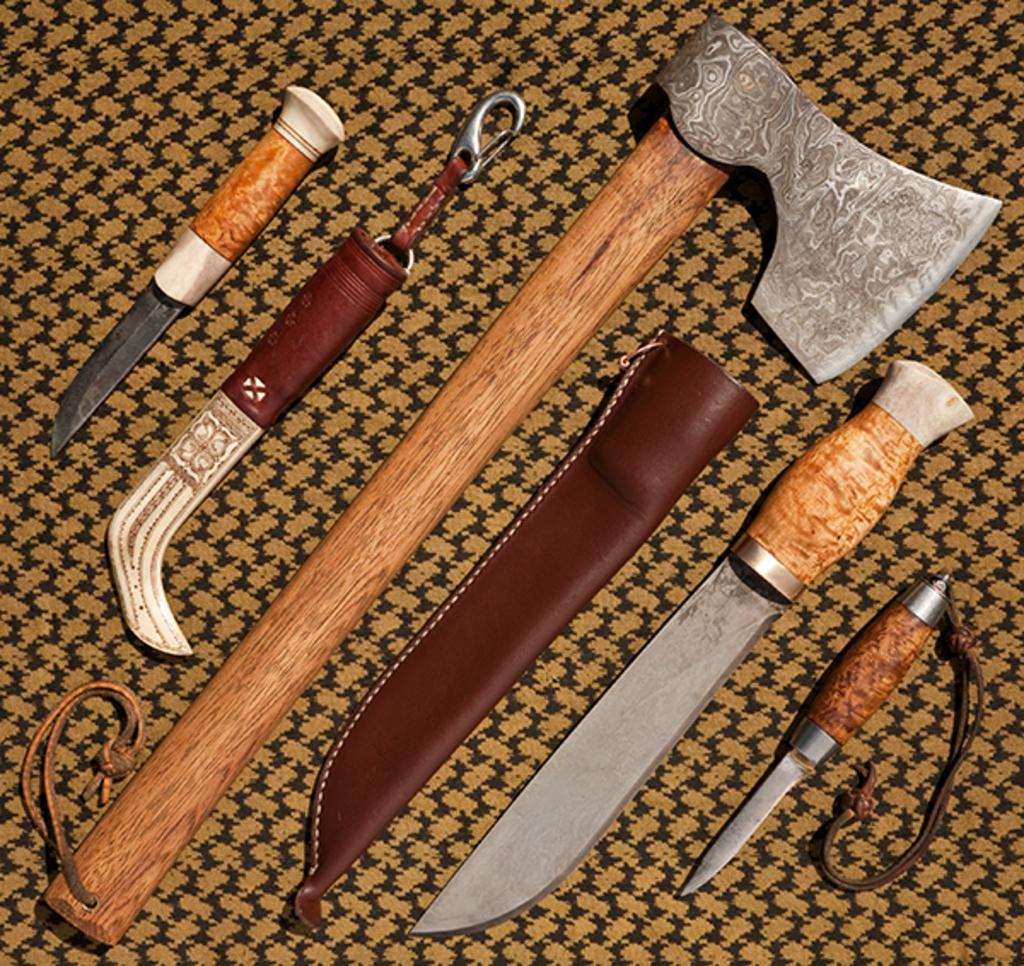What objects are present in the image? There are weapons in the image. Where are the weapons located? The weapons are placed on a mat. What type of meat is being used as an ornament on the weapons in the image? There is no meat or ornament present on the weapons in the image; the weapons are simply placed on a mat. 